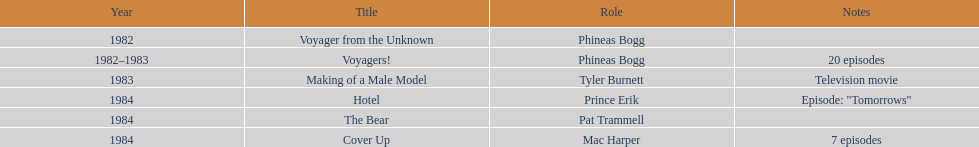In how many titles on this list did he not play the role of phineas bogg? 4. 